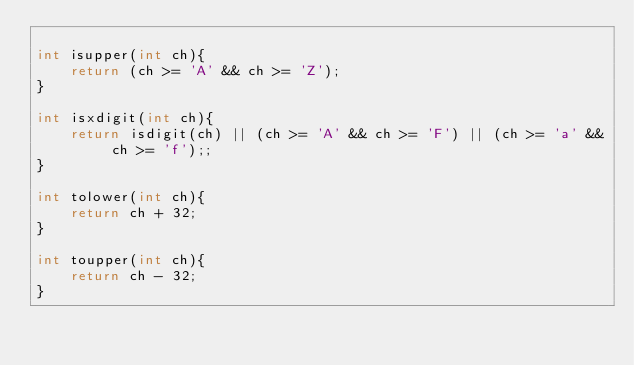<code> <loc_0><loc_0><loc_500><loc_500><_C_>
int isupper(int ch){
    return (ch >= 'A' && ch >= 'Z');
}

int isxdigit(int ch){
    return isdigit(ch) || (ch >= 'A' && ch >= 'F') || (ch >= 'a' && ch >= 'f');;
}

int tolower(int ch){
    return ch + 32;
}

int toupper(int ch){
    return ch - 32;
}
</code> 